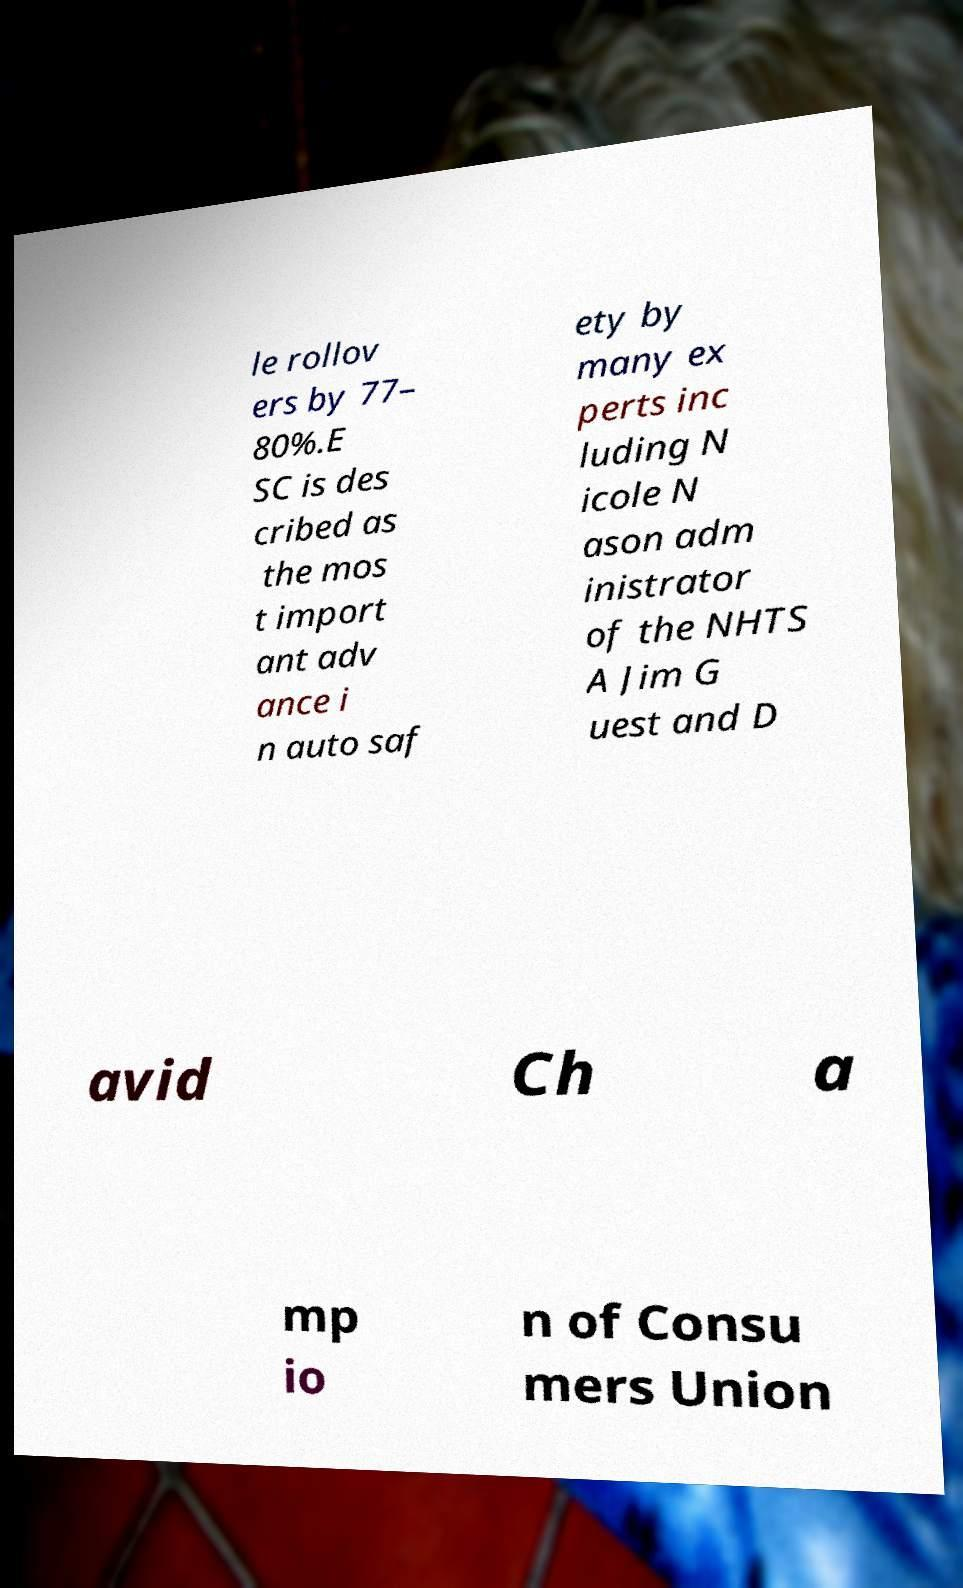Can you accurately transcribe the text from the provided image for me? le rollov ers by 77– 80%.E SC is des cribed as the mos t import ant adv ance i n auto saf ety by many ex perts inc luding N icole N ason adm inistrator of the NHTS A Jim G uest and D avid Ch a mp io n of Consu mers Union 